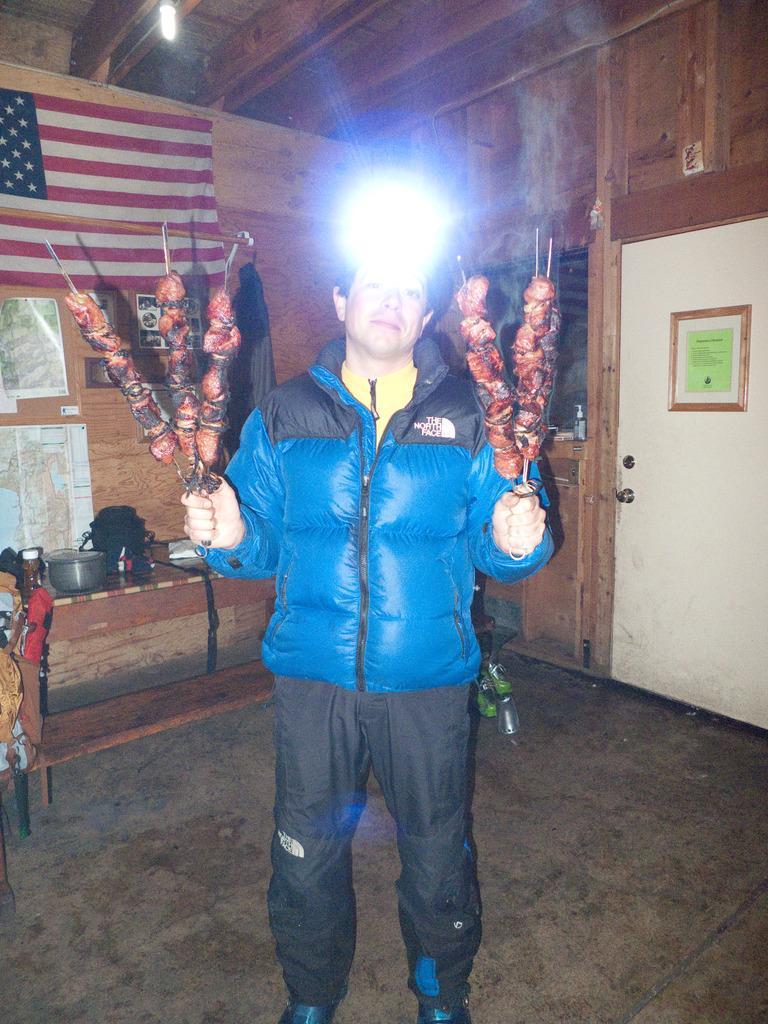Can you describe this image briefly? In this image I can see a person wearing jacket which is blue and black in color and black colored pant is standing and holding few kebab sticks in his hand and I can see a torch light on his head. In the background I can see a flag attached to the wall and few laps attached to the wall and a table on which I can see a bowl, a bag and few other objects. To the right side of the image I can see a white colored door and a photo frame attached to it. 